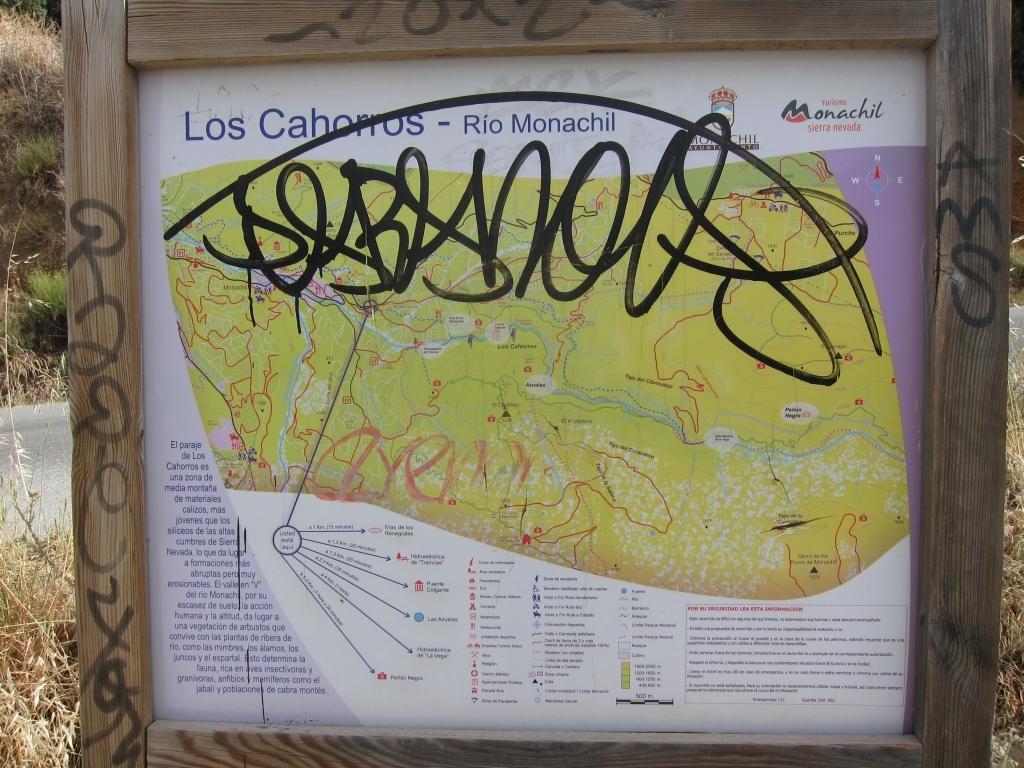What river is represented on the map?
Make the answer very short. Los cahorros. What is the name of the area?
Ensure brevity in your answer.  Los cahorros. 